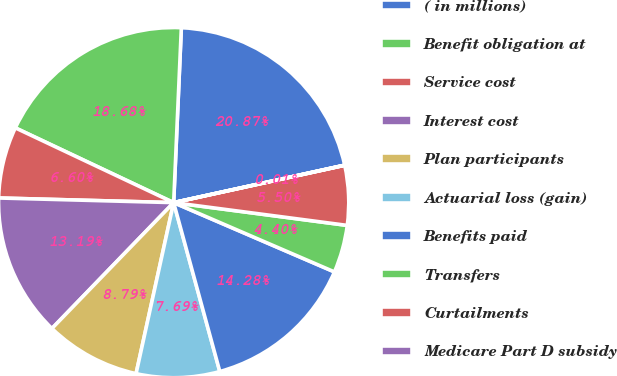Convert chart. <chart><loc_0><loc_0><loc_500><loc_500><pie_chart><fcel>( in millions)<fcel>Benefit obligation at<fcel>Service cost<fcel>Interest cost<fcel>Plan participants<fcel>Actuarial loss (gain)<fcel>Benefits paid<fcel>Transfers<fcel>Curtailments<fcel>Medicare Part D subsidy<nl><fcel>20.87%<fcel>18.68%<fcel>6.6%<fcel>13.19%<fcel>8.79%<fcel>7.69%<fcel>14.28%<fcel>4.4%<fcel>5.5%<fcel>0.01%<nl></chart> 